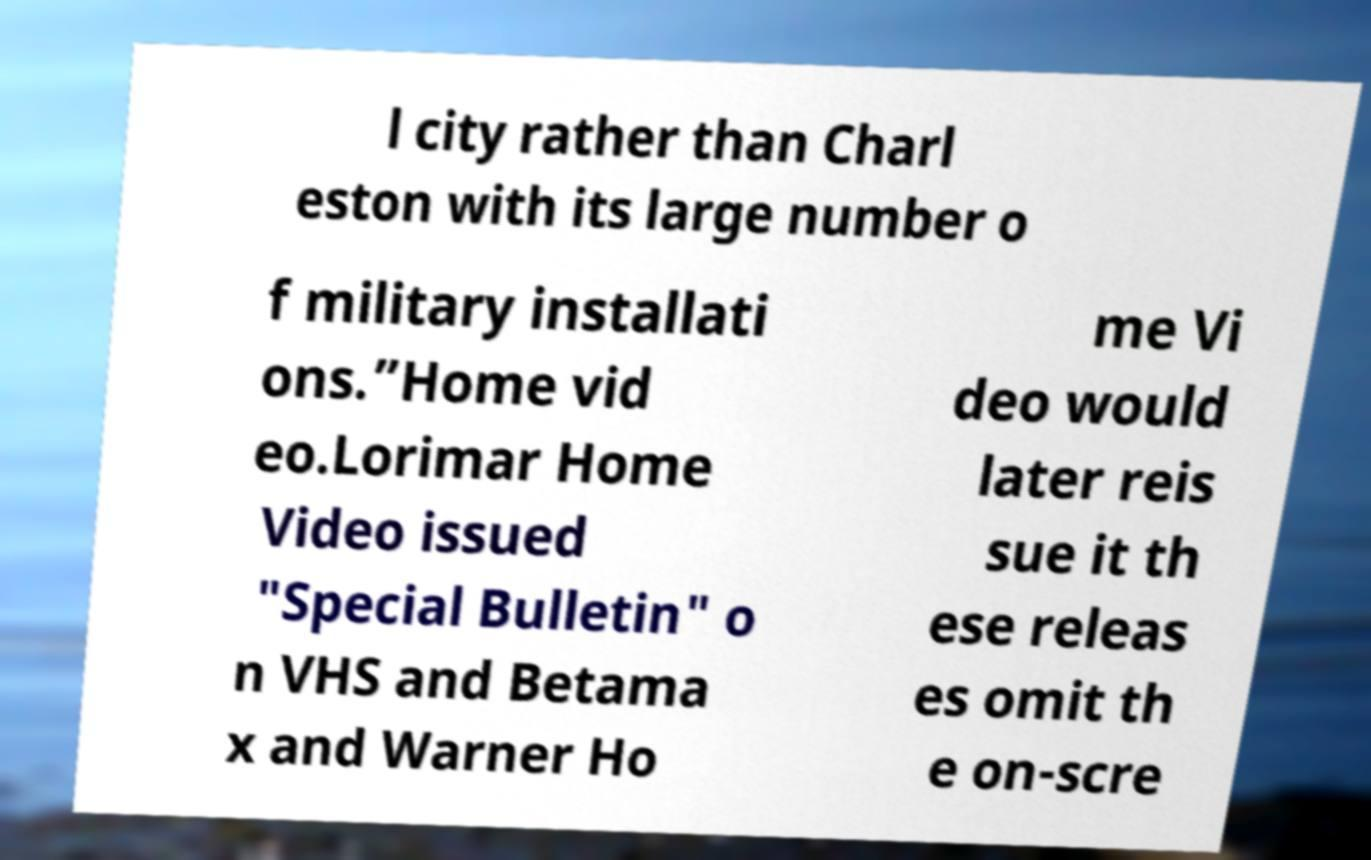I need the written content from this picture converted into text. Can you do that? l city rather than Charl eston with its large number o f military installati ons.”Home vid eo.Lorimar Home Video issued "Special Bulletin" o n VHS and Betama x and Warner Ho me Vi deo would later reis sue it th ese releas es omit th e on-scre 